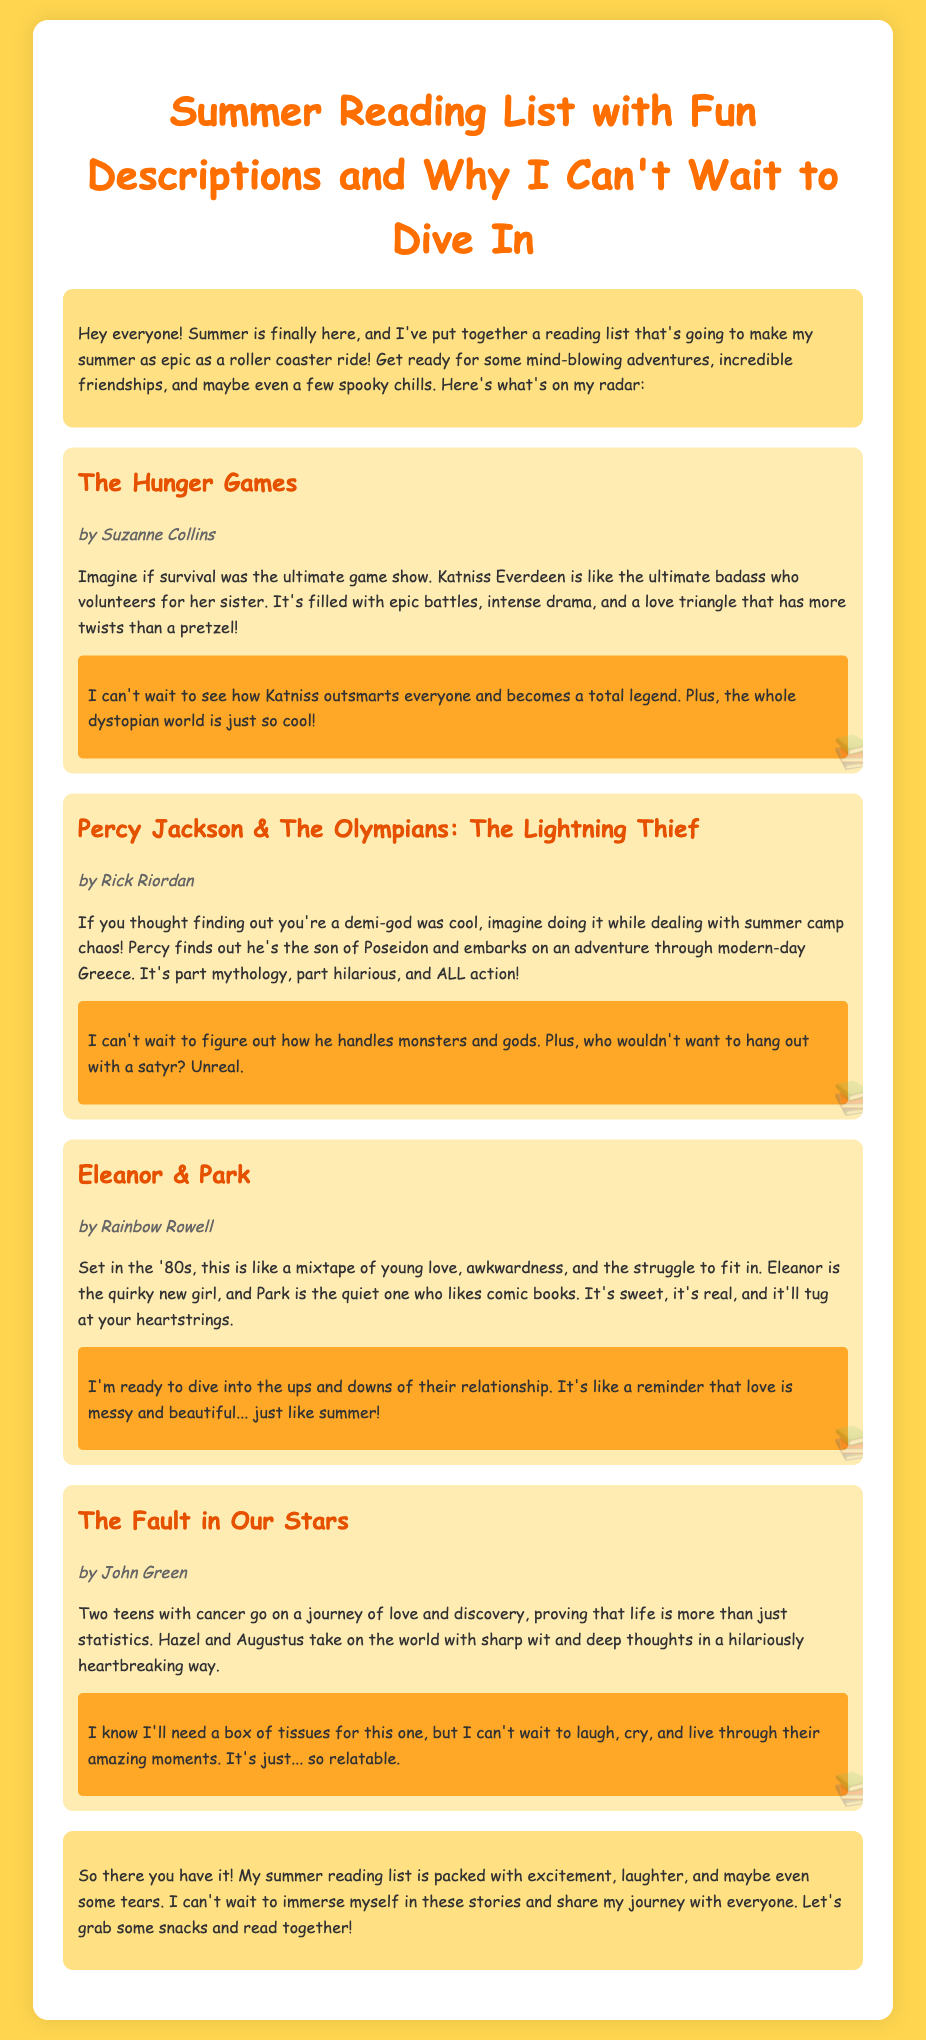What is the title of the document? The title of the document is stated at the top of the HTML, summarizing its purpose.
Answer: Summer Reading List with Fun Descriptions and Why I Can't Wait to Dive In Who is the author of "The Hunger Games"? The author's name is attributed to the book in the document.
Answer: Suzanne Collins What genre does "Eleanor & Park" belong to? The document describes "Eleanor & Park" as a young love story set in the '80s, indicating its genre.
Answer: Young Adult Which book features a protagonist who is a son of Poseidon? The description mentions Percy, who has a connection to Poseidon.
Answer: Percy Jackson & The Olympians: The Lightning Thief How many books are listed in the Summer Reading List? The total number of book descriptions provided in the document indicates the list's length.
Answer: Four What emotion is associated with "The Fault in Our Stars"? The description highlights a blend of sentimentality and deep feelings related to the book's themes.
Answer: Heartbreaking Which book's description includes the phrase "ultimate badass"? The document specifically uses this phrase while discussing the character in the book.
Answer: The Hunger Games What does the summer reading list promise in the conclusion? The conclusion summarizes what the reader can expect from engaging with the list.
Answer: Excitement, laughter, and maybe even some tears 